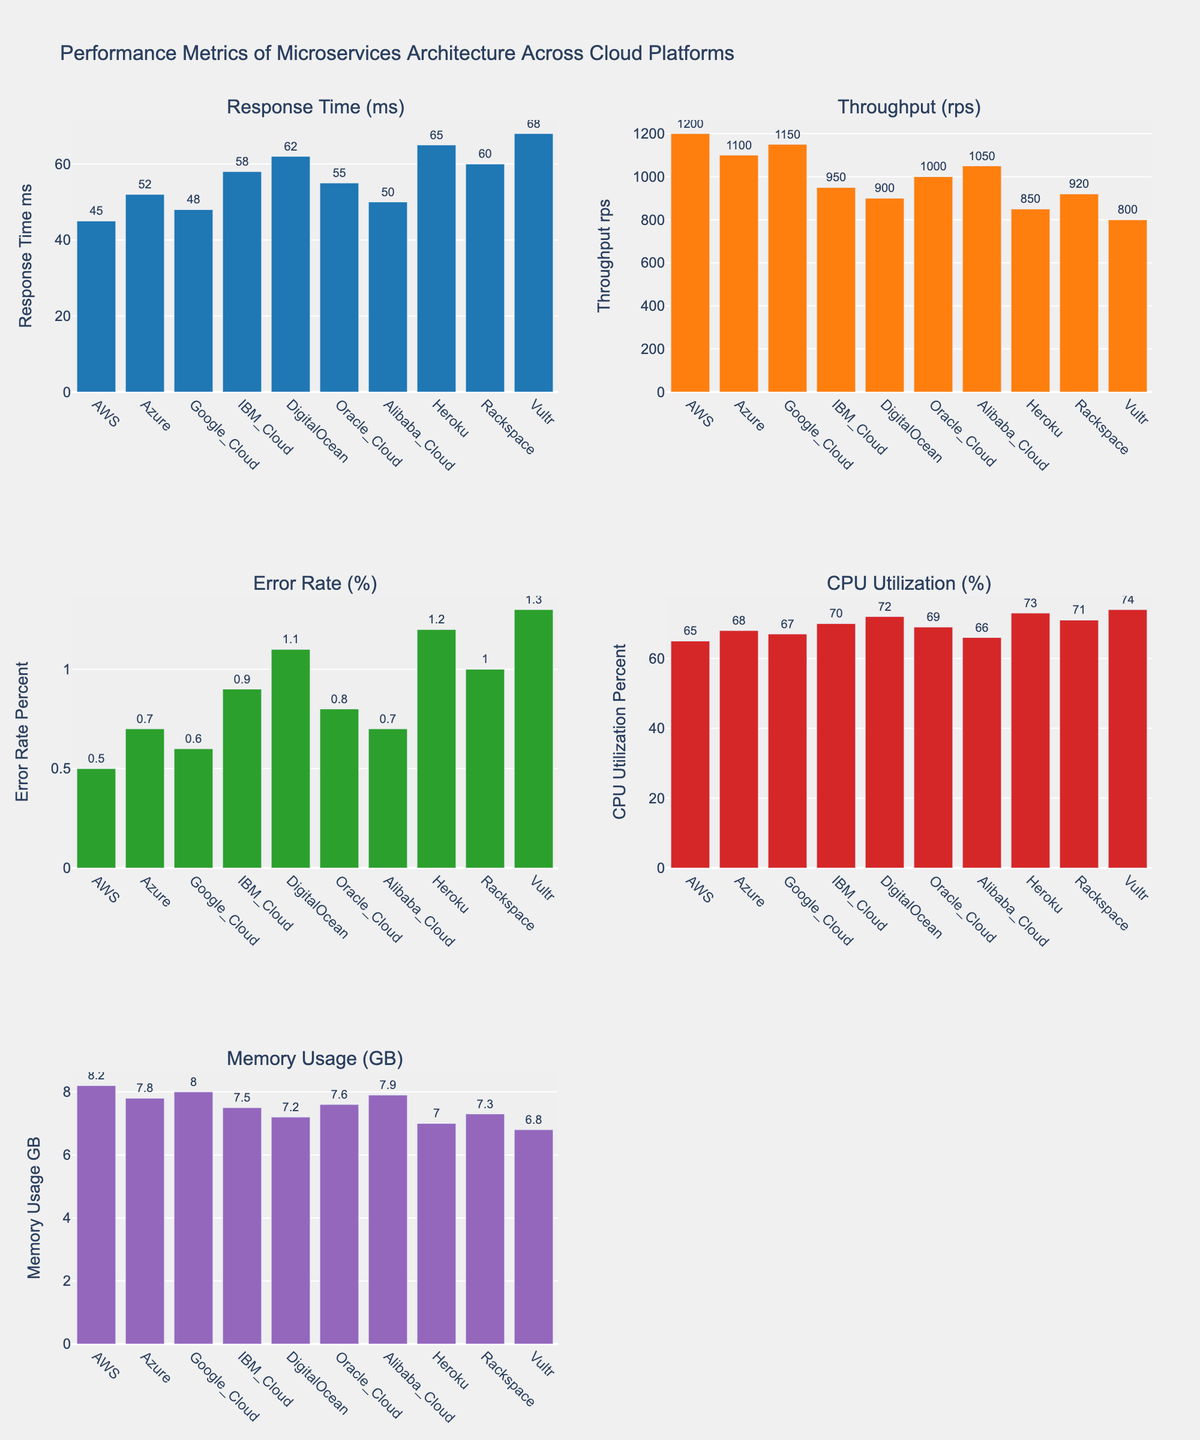What's the title of the figure? The title is displayed at the top center of the figure and reads "Ice Dance Music Genres Across Decades".
Answer: Ice Dance Music Genres Across Decades Which genre had the highest use during the 2020s? By looking at the bar heights in the 2020s category, the Contemporary genre has the tallest bar, indicating it was the most used.
Answer: Contemporary How has the use of Classical music changed from the 1950s to the 2020s? The Classical genre's bars show a decline from 45 in the 1950s down to 10 in the 2020s. This indicates a decreasing trend over the decades.
Answer: Decreased What is the combined total of Latin music usage in the 1960s and 1990s? From the figure, the Latin music bars in the 1960s and 1990s are 25 and 30 respectively. Adding these values gives a total of 55.
Answer: 55 Which genre had a steady number across three consecutive decades? The Folk genre has a consistently low number of 5 across multiple decades from the 1960s to the 2020s, showing stability.
Answer: Folk Between Jazz and Classical genres, which one saw a greater increase in usage from the 2000s to 2010s? Comparing the bars, Jazz increased from 20 in the 2000s to 25 in the 2010s (+5), while Classical decreased. Jazz's usage saw a positive change.
Answer: Jazz How much did the usage of Contemporary music increase from the 1950s to the 2020s? The Contemporary music bar shows an increase from 5 in the 1950s to 40 in the 2020s. This calculates to an increase of 35.
Answer: 35 What is the average usage of Jazz music from the 1950s to the 2020s? Adding up the Jazz values (15, 20, 15, 10, 15, 20, 25, 30) gives 150. Divide this by 8 decades to get an average of 18.75.
Answer: 18.75 In which decade did Latin music see a peak in its usage? Observing the bar heights for Latin music across all decades, the highest bar is in the 1980s.
Answer: 1980s Which decade saw the highest increase in Contemporary music usage compared to the previous decade? By comparing the heights of the bars for each decade incrementally, the largest jump is from the 2010s (35) to the 2020s (40), an increase of 5.
Answer: 2020s 